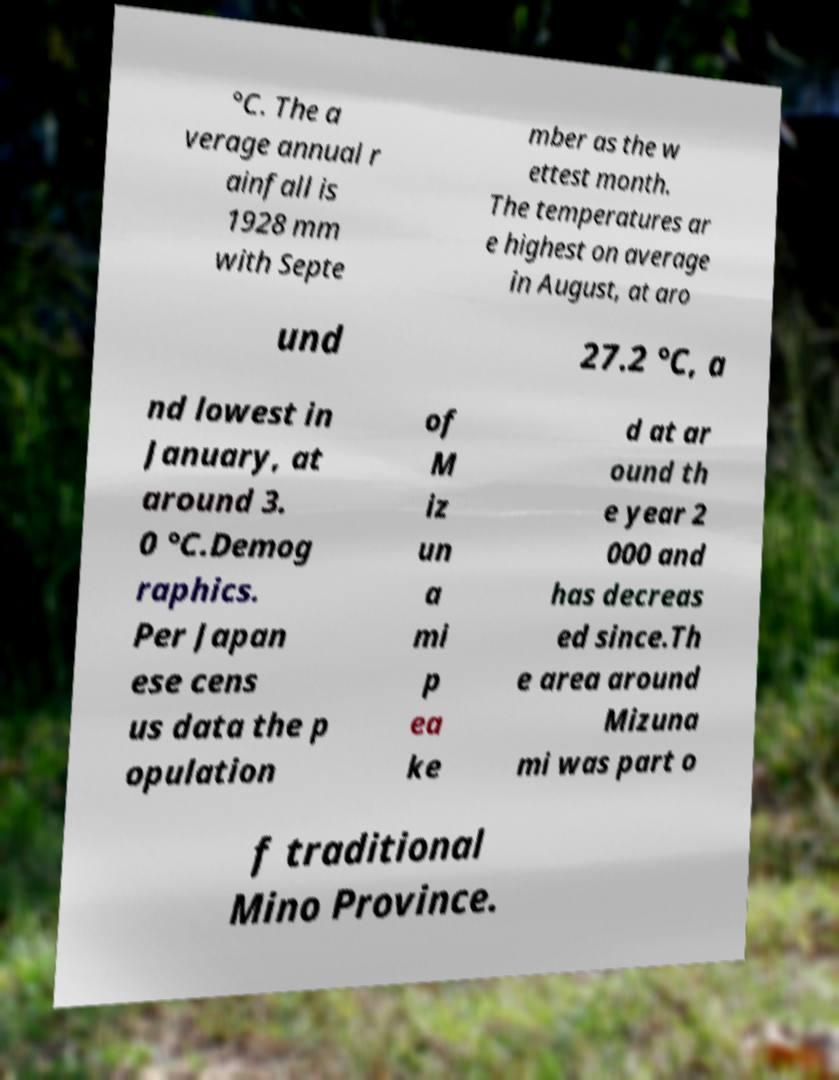There's text embedded in this image that I need extracted. Can you transcribe it verbatim? °C. The a verage annual r ainfall is 1928 mm with Septe mber as the w ettest month. The temperatures ar e highest on average in August, at aro und 27.2 °C, a nd lowest in January, at around 3. 0 °C.Demog raphics. Per Japan ese cens us data the p opulation of M iz un a mi p ea ke d at ar ound th e year 2 000 and has decreas ed since.Th e area around Mizuna mi was part o f traditional Mino Province. 